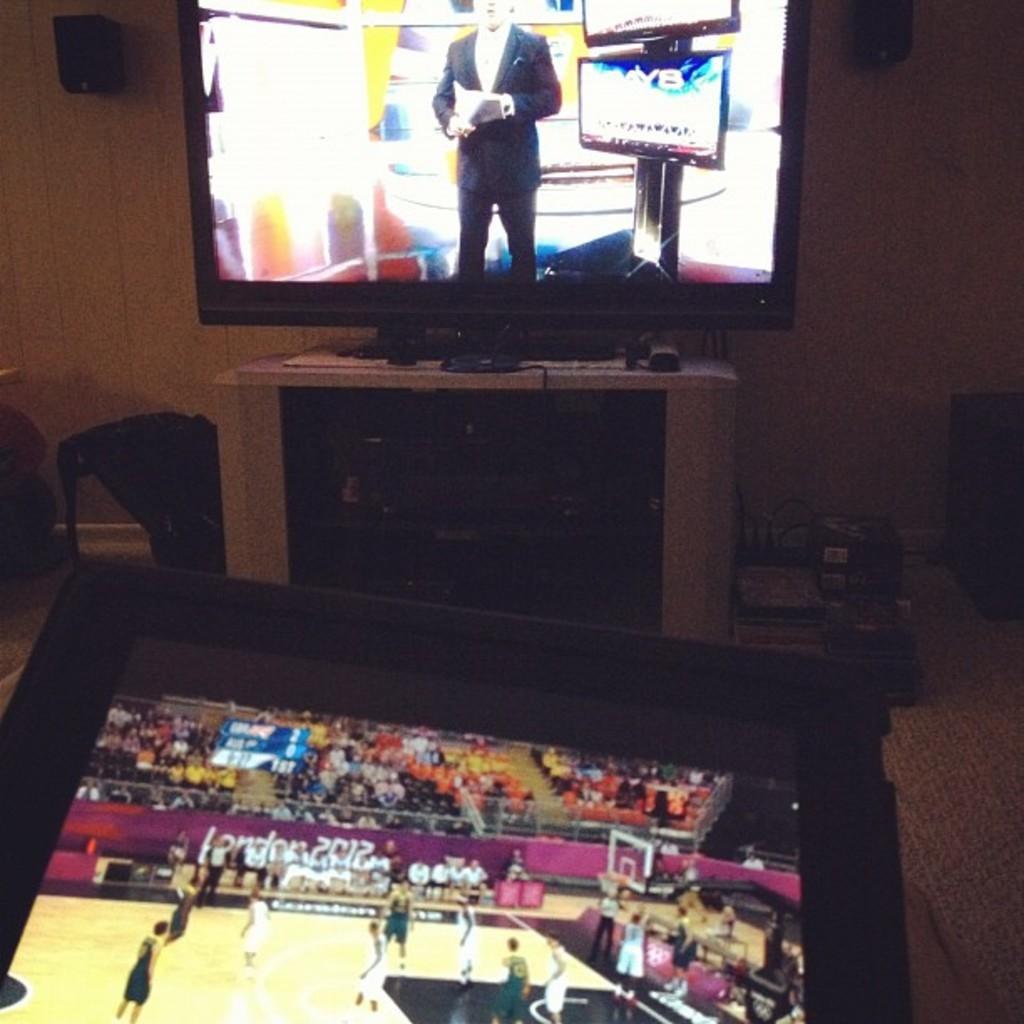Can you describe this image briefly? In this picture there is a inside view of the room. In the front we can see the television screen placed on the table top. Behind there is a yellow color wall with two speakers. On the bottom side there is a another television on the floor.. 